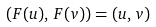Convert formula to latex. <formula><loc_0><loc_0><loc_500><loc_500>( F ( u ) , \, F ( v ) ) = ( u , \, v )</formula> 